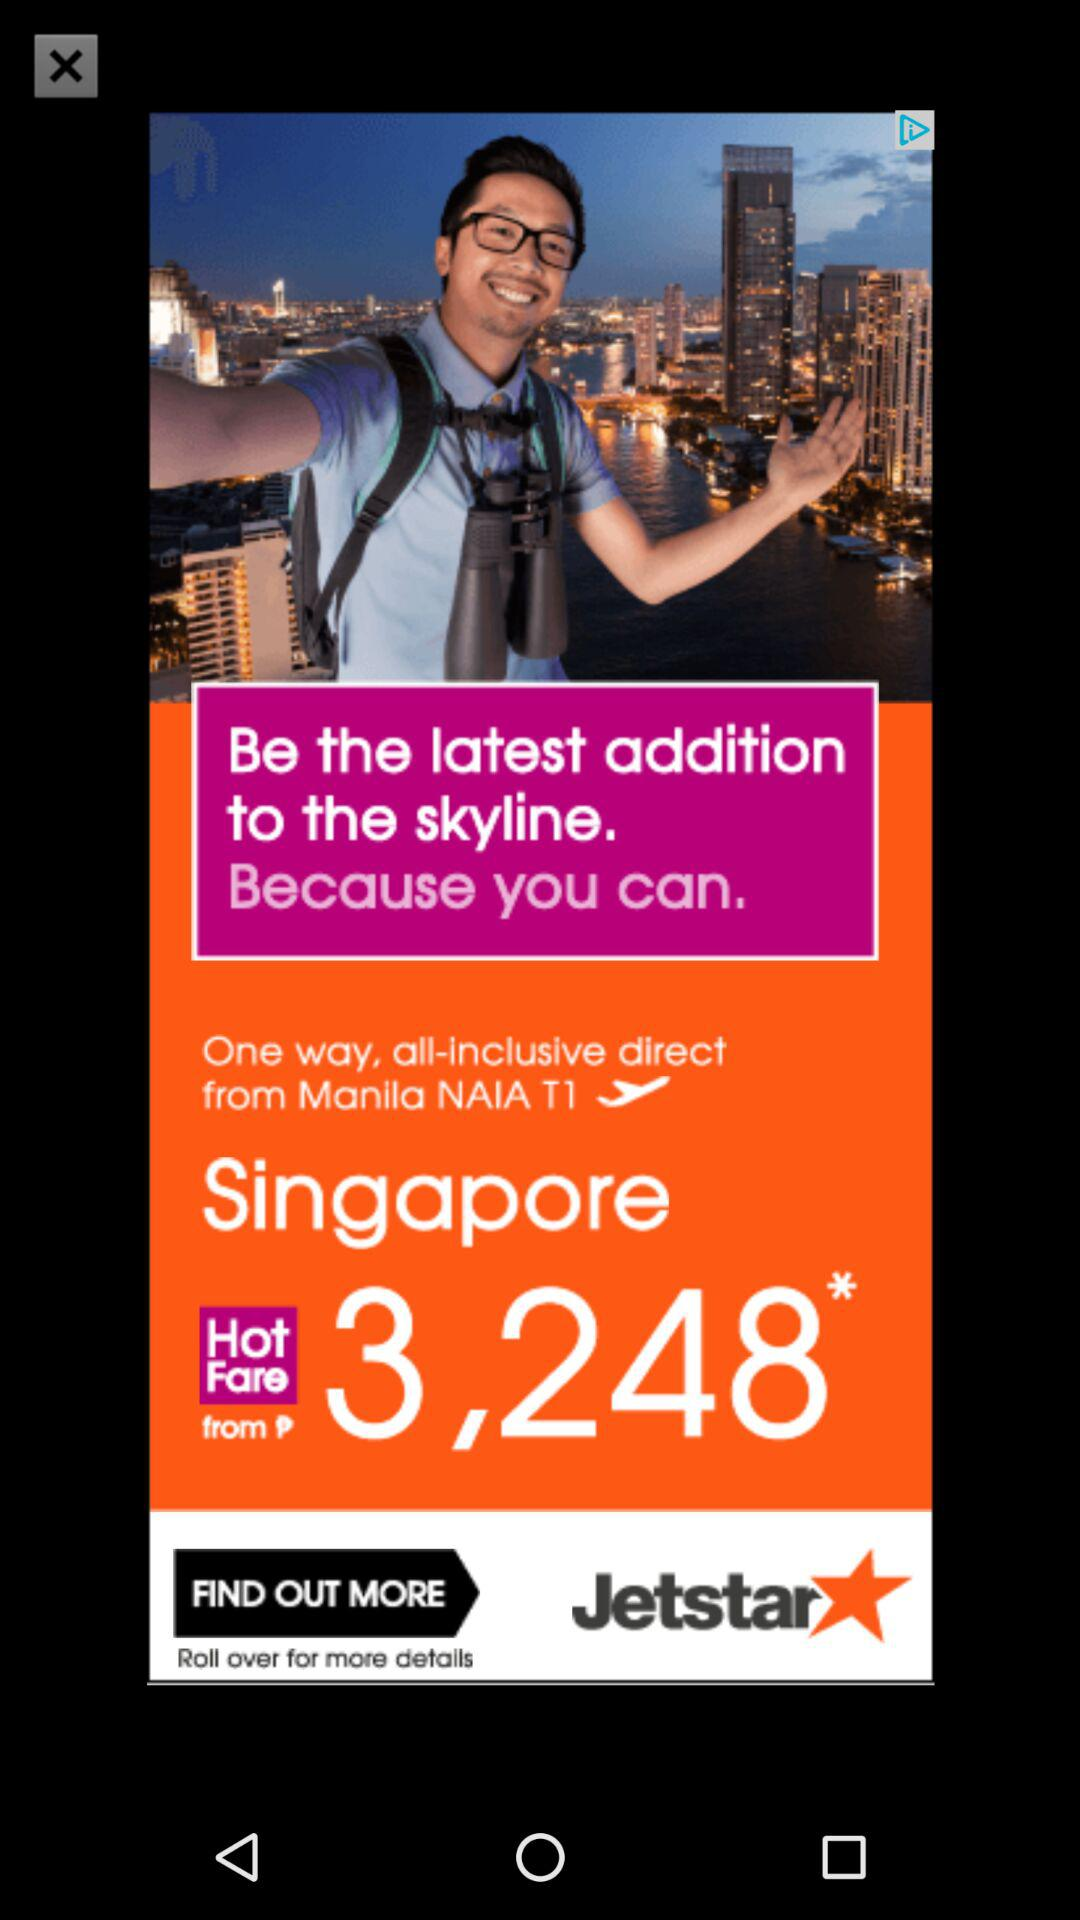What is the starting fare for Singapore? The starting fare is ₱‎3,248. 